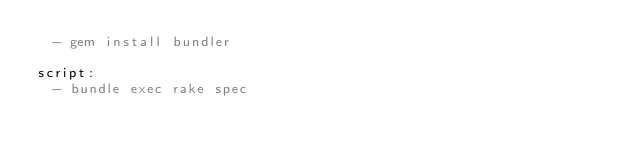Convert code to text. <code><loc_0><loc_0><loc_500><loc_500><_YAML_>  - gem install bundler

script:
  - bundle exec rake spec
</code> 